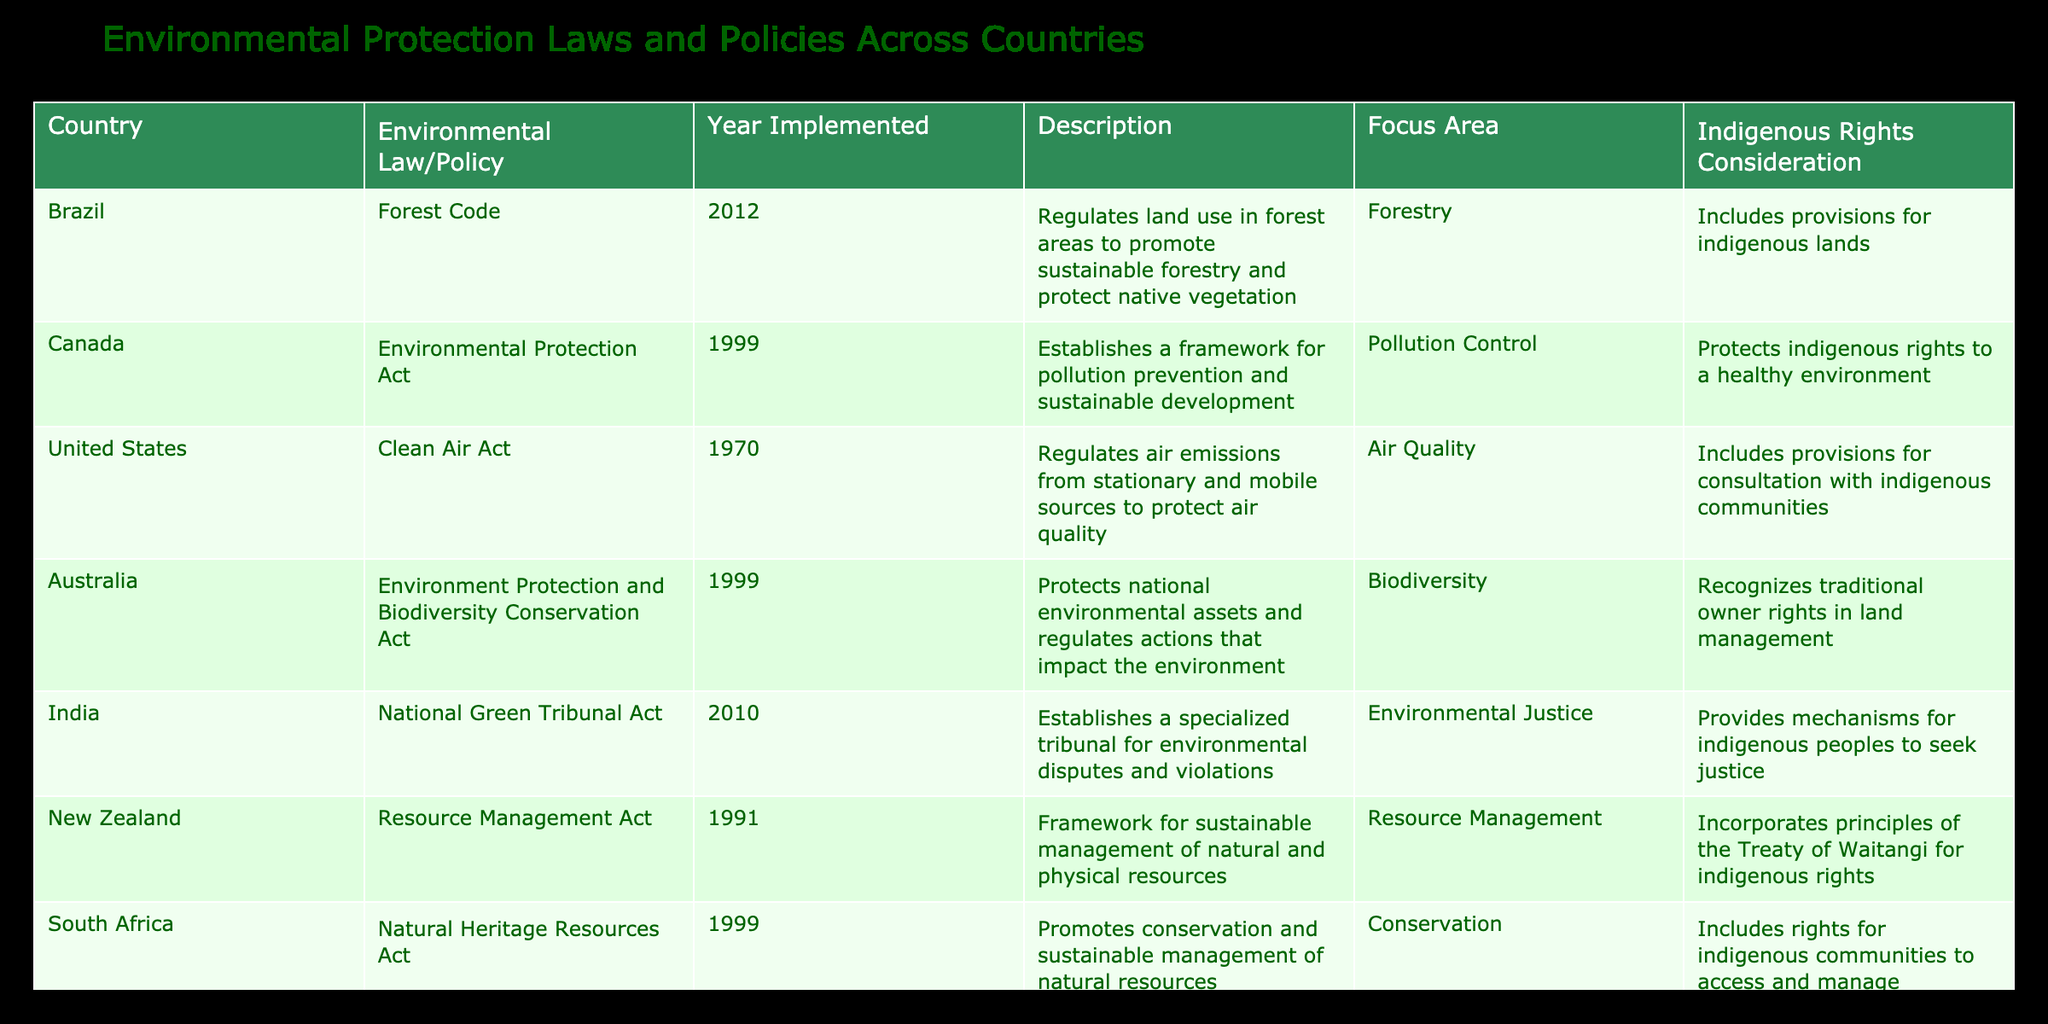What is the Environmental Law/Policy implemented in Canada? The table indicates that Canada has the Environmental Protection Act as their environmental law/policy.
Answer: Environmental Protection Act Which country implemented the Forestry Law in 2005? According to the table, Colombia is the country that implemented the Forestry Law in 2005.
Answer: Colombia How many countries have environmental laws or policies that consider indigenous rights? Six countries (Brazil, Canada, United States, Australia, India, and Mexico) have environmental laws or policies that include provisions for indigenous rights.
Answer: Six Which law/policy focuses on biodiversity and was enacted in 1999? The Environment Protection and Biodiversity Conservation Act is described as focusing on biodiversity and was enacted in 1999 in Australia.
Answer: Environment Protection and Biodiversity Conservation Act Is the National Green Tribunal Act focused on pollution control? No, the National Green Tribunal Act focuses on environmental justice, not pollution control.
Answer: No What year was the General Law on Ecological Balance and the Environment enacted in Mexico? The table specifies that the General Law on Ecological Balance and the Environment was enacted in 1988.
Answer: 1988 Which country's law is aimed at regulating air emissions? The Clean Air Act of the United States is aimed at regulating air emissions.
Answer: United States Count the number of countries whose laws/policies are specifically focused on forestry. There are three countries with laws/policies focused on forestry: Brazil (Forest Code), Colombia (Forestry Law), and Mexico (General Law on Ecological Balance and the Environment). The total count is 3.
Answer: 3 Do all countries listed have a consideration for indigenous rights in their environmental policies? No, not all countries have such considerations; for instance, South Africa's policy includes rights for indigenous communities but other laws may not mention indigenous rights.
Answer: No 